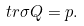<formula> <loc_0><loc_0><loc_500><loc_500>\ t r \sigma Q = p .</formula> 